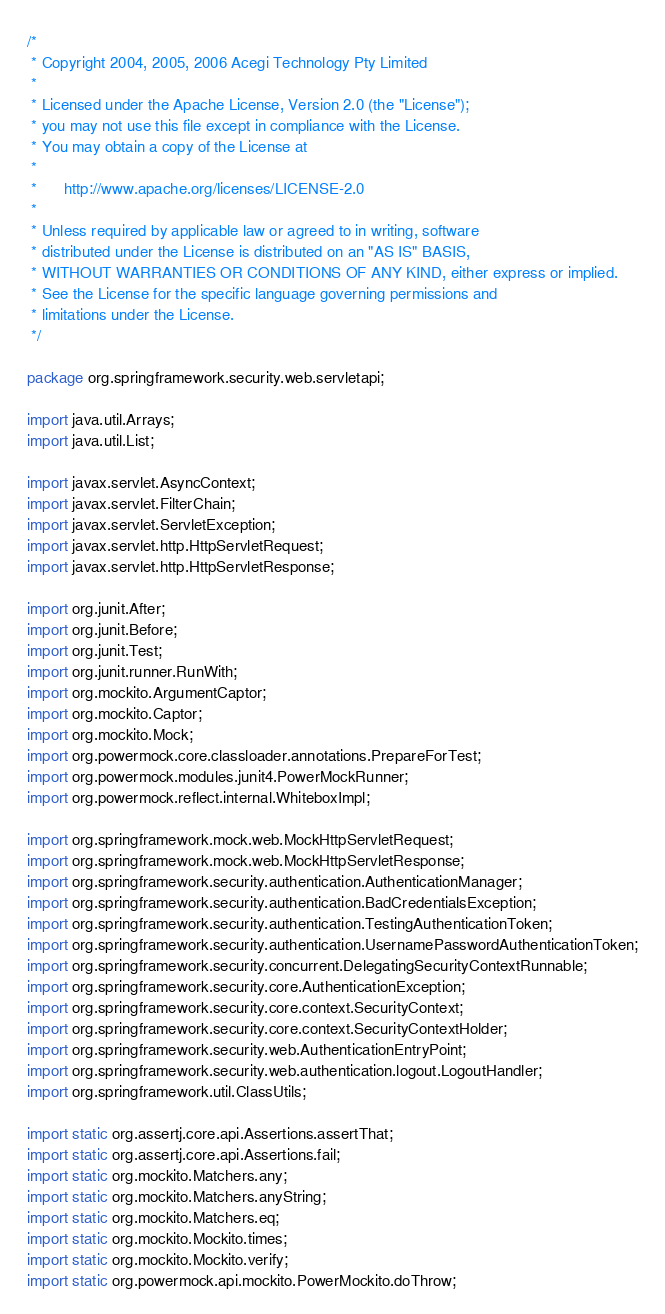Convert code to text. <code><loc_0><loc_0><loc_500><loc_500><_Java_>/*
 * Copyright 2004, 2005, 2006 Acegi Technology Pty Limited
 *
 * Licensed under the Apache License, Version 2.0 (the "License");
 * you may not use this file except in compliance with the License.
 * You may obtain a copy of the License at
 *
 *      http://www.apache.org/licenses/LICENSE-2.0
 *
 * Unless required by applicable law or agreed to in writing, software
 * distributed under the License is distributed on an "AS IS" BASIS,
 * WITHOUT WARRANTIES OR CONDITIONS OF ANY KIND, either express or implied.
 * See the License for the specific language governing permissions and
 * limitations under the License.
 */

package org.springframework.security.web.servletapi;

import java.util.Arrays;
import java.util.List;

import javax.servlet.AsyncContext;
import javax.servlet.FilterChain;
import javax.servlet.ServletException;
import javax.servlet.http.HttpServletRequest;
import javax.servlet.http.HttpServletResponse;

import org.junit.After;
import org.junit.Before;
import org.junit.Test;
import org.junit.runner.RunWith;
import org.mockito.ArgumentCaptor;
import org.mockito.Captor;
import org.mockito.Mock;
import org.powermock.core.classloader.annotations.PrepareForTest;
import org.powermock.modules.junit4.PowerMockRunner;
import org.powermock.reflect.internal.WhiteboxImpl;

import org.springframework.mock.web.MockHttpServletRequest;
import org.springframework.mock.web.MockHttpServletResponse;
import org.springframework.security.authentication.AuthenticationManager;
import org.springframework.security.authentication.BadCredentialsException;
import org.springframework.security.authentication.TestingAuthenticationToken;
import org.springframework.security.authentication.UsernamePasswordAuthenticationToken;
import org.springframework.security.concurrent.DelegatingSecurityContextRunnable;
import org.springframework.security.core.AuthenticationException;
import org.springframework.security.core.context.SecurityContext;
import org.springframework.security.core.context.SecurityContextHolder;
import org.springframework.security.web.AuthenticationEntryPoint;
import org.springframework.security.web.authentication.logout.LogoutHandler;
import org.springframework.util.ClassUtils;

import static org.assertj.core.api.Assertions.assertThat;
import static org.assertj.core.api.Assertions.fail;
import static org.mockito.Matchers.any;
import static org.mockito.Matchers.anyString;
import static org.mockito.Matchers.eq;
import static org.mockito.Mockito.times;
import static org.mockito.Mockito.verify;
import static org.powermock.api.mockito.PowerMockito.doThrow;</code> 